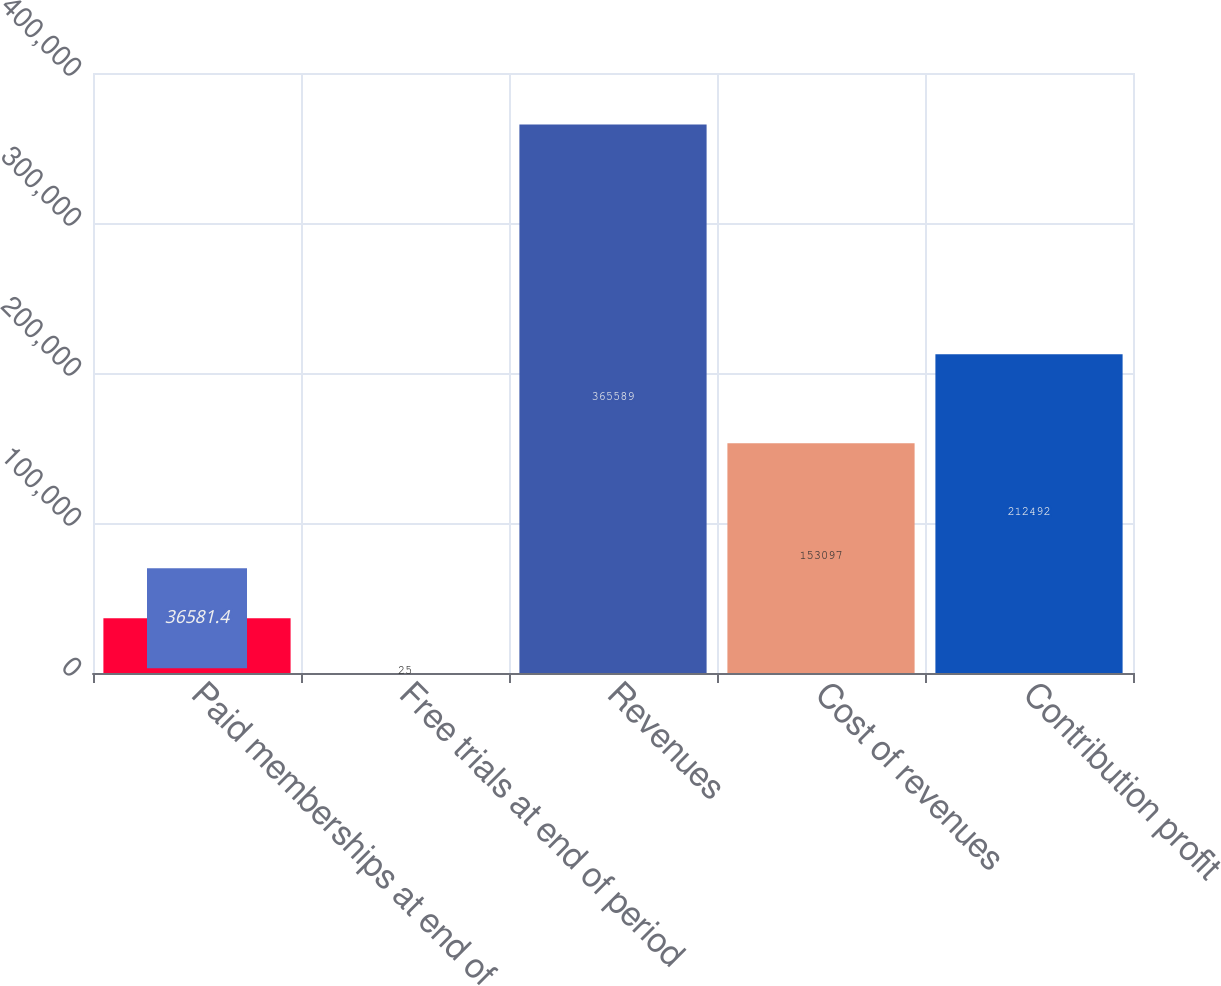<chart> <loc_0><loc_0><loc_500><loc_500><bar_chart><fcel>Paid memberships at end of<fcel>Free trials at end of period<fcel>Revenues<fcel>Cost of revenues<fcel>Contribution profit<nl><fcel>36581.4<fcel>25<fcel>365589<fcel>153097<fcel>212492<nl></chart> 